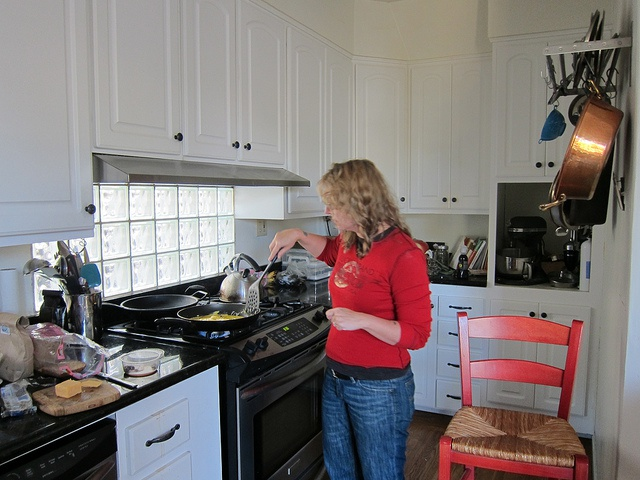Describe the objects in this image and their specific colors. I can see people in darkgray, brown, blue, gray, and navy tones, chair in darkgray, maroon, brown, and gray tones, oven in darkgray, black, and gray tones, bowl in darkgray, lightgray, gray, and black tones, and book in darkgray, gray, black, and maroon tones in this image. 